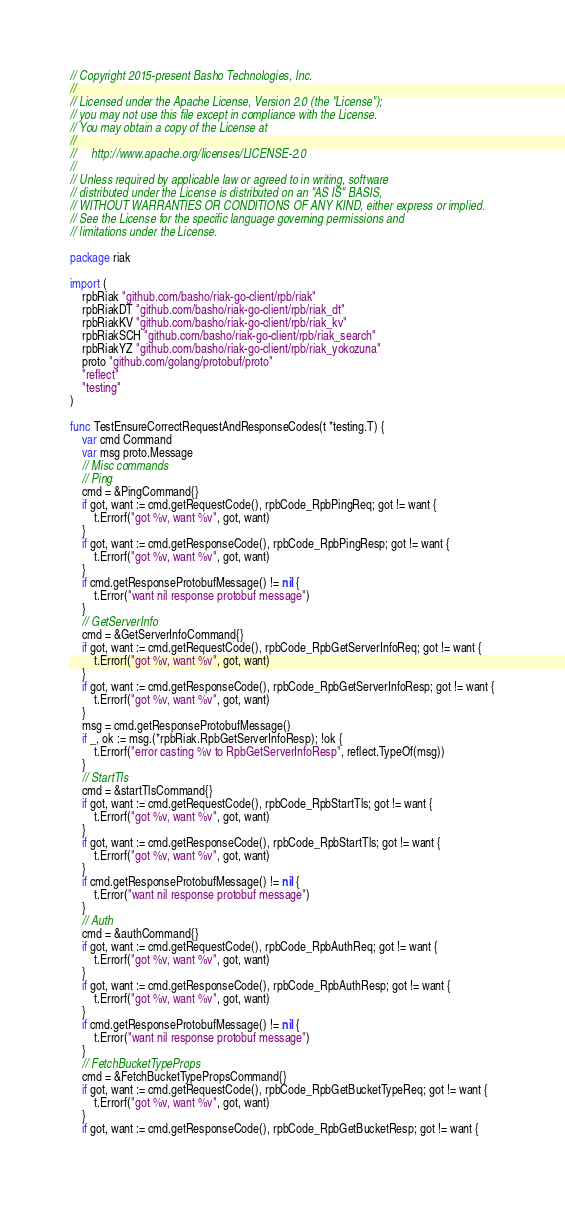<code> <loc_0><loc_0><loc_500><loc_500><_Go_>// Copyright 2015-present Basho Technologies, Inc.
//
// Licensed under the Apache License, Version 2.0 (the "License");
// you may not use this file except in compliance with the License.
// You may obtain a copy of the License at
//
//     http://www.apache.org/licenses/LICENSE-2.0
//
// Unless required by applicable law or agreed to in writing, software
// distributed under the License is distributed on an "AS IS" BASIS,
// WITHOUT WARRANTIES OR CONDITIONS OF ANY KIND, either express or implied.
// See the License for the specific language governing permissions and
// limitations under the License.

package riak

import (
	rpbRiak "github.com/basho/riak-go-client/rpb/riak"
	rpbRiakDT "github.com/basho/riak-go-client/rpb/riak_dt"
	rpbRiakKV "github.com/basho/riak-go-client/rpb/riak_kv"
	rpbRiakSCH "github.com/basho/riak-go-client/rpb/riak_search"
	rpbRiakYZ "github.com/basho/riak-go-client/rpb/riak_yokozuna"
	proto "github.com/golang/protobuf/proto"
	"reflect"
	"testing"
)

func TestEnsureCorrectRequestAndResponseCodes(t *testing.T) {
	var cmd Command
	var msg proto.Message
	// Misc commands
	// Ping
	cmd = &PingCommand{}
	if got, want := cmd.getRequestCode(), rpbCode_RpbPingReq; got != want {
		t.Errorf("got %v, want %v", got, want)
	}
	if got, want := cmd.getResponseCode(), rpbCode_RpbPingResp; got != want {
		t.Errorf("got %v, want %v", got, want)
	}
	if cmd.getResponseProtobufMessage() != nil {
		t.Error("want nil response protobuf message")
	}
	// GetServerInfo
	cmd = &GetServerInfoCommand{}
	if got, want := cmd.getRequestCode(), rpbCode_RpbGetServerInfoReq; got != want {
		t.Errorf("got %v, want %v", got, want)
	}
	if got, want := cmd.getResponseCode(), rpbCode_RpbGetServerInfoResp; got != want {
		t.Errorf("got %v, want %v", got, want)
	}
	msg = cmd.getResponseProtobufMessage()
	if _, ok := msg.(*rpbRiak.RpbGetServerInfoResp); !ok {
		t.Errorf("error casting %v to RpbGetServerInfoResp", reflect.TypeOf(msg))
	}
	// StartTls
	cmd = &startTlsCommand{}
	if got, want := cmd.getRequestCode(), rpbCode_RpbStartTls; got != want {
		t.Errorf("got %v, want %v", got, want)
	}
	if got, want := cmd.getResponseCode(), rpbCode_RpbStartTls; got != want {
		t.Errorf("got %v, want %v", got, want)
	}
	if cmd.getResponseProtobufMessage() != nil {
		t.Error("want nil response protobuf message")
	}
	// Auth
	cmd = &authCommand{}
	if got, want := cmd.getRequestCode(), rpbCode_RpbAuthReq; got != want {
		t.Errorf("got %v, want %v", got, want)
	}
	if got, want := cmd.getResponseCode(), rpbCode_RpbAuthResp; got != want {
		t.Errorf("got %v, want %v", got, want)
	}
	if cmd.getResponseProtobufMessage() != nil {
		t.Error("want nil response protobuf message")
	}
	// FetchBucketTypeProps
	cmd = &FetchBucketTypePropsCommand{}
	if got, want := cmd.getRequestCode(), rpbCode_RpbGetBucketTypeReq; got != want {
		t.Errorf("got %v, want %v", got, want)
	}
	if got, want := cmd.getResponseCode(), rpbCode_RpbGetBucketResp; got != want {</code> 